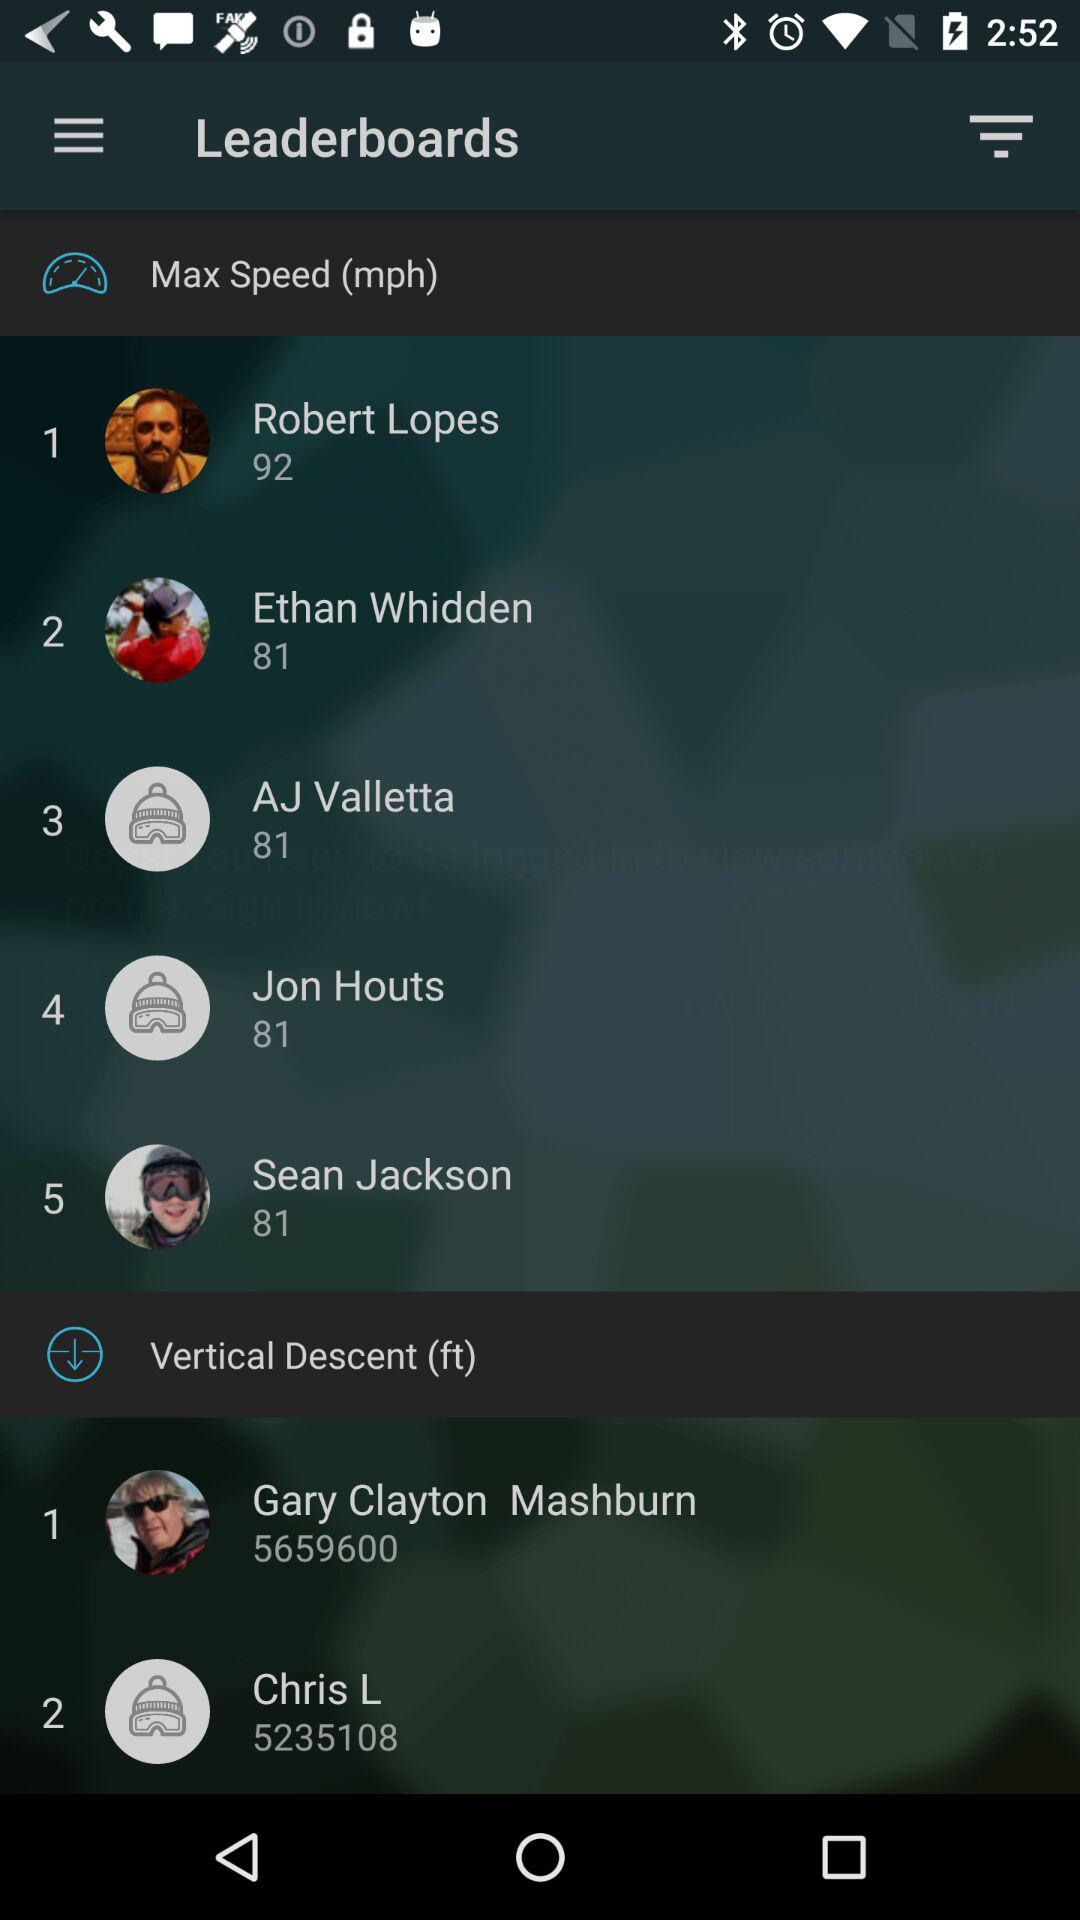What is the maximum speed of Robert Lopes? The maximum speed of Robert Lopes is 92 mph. 